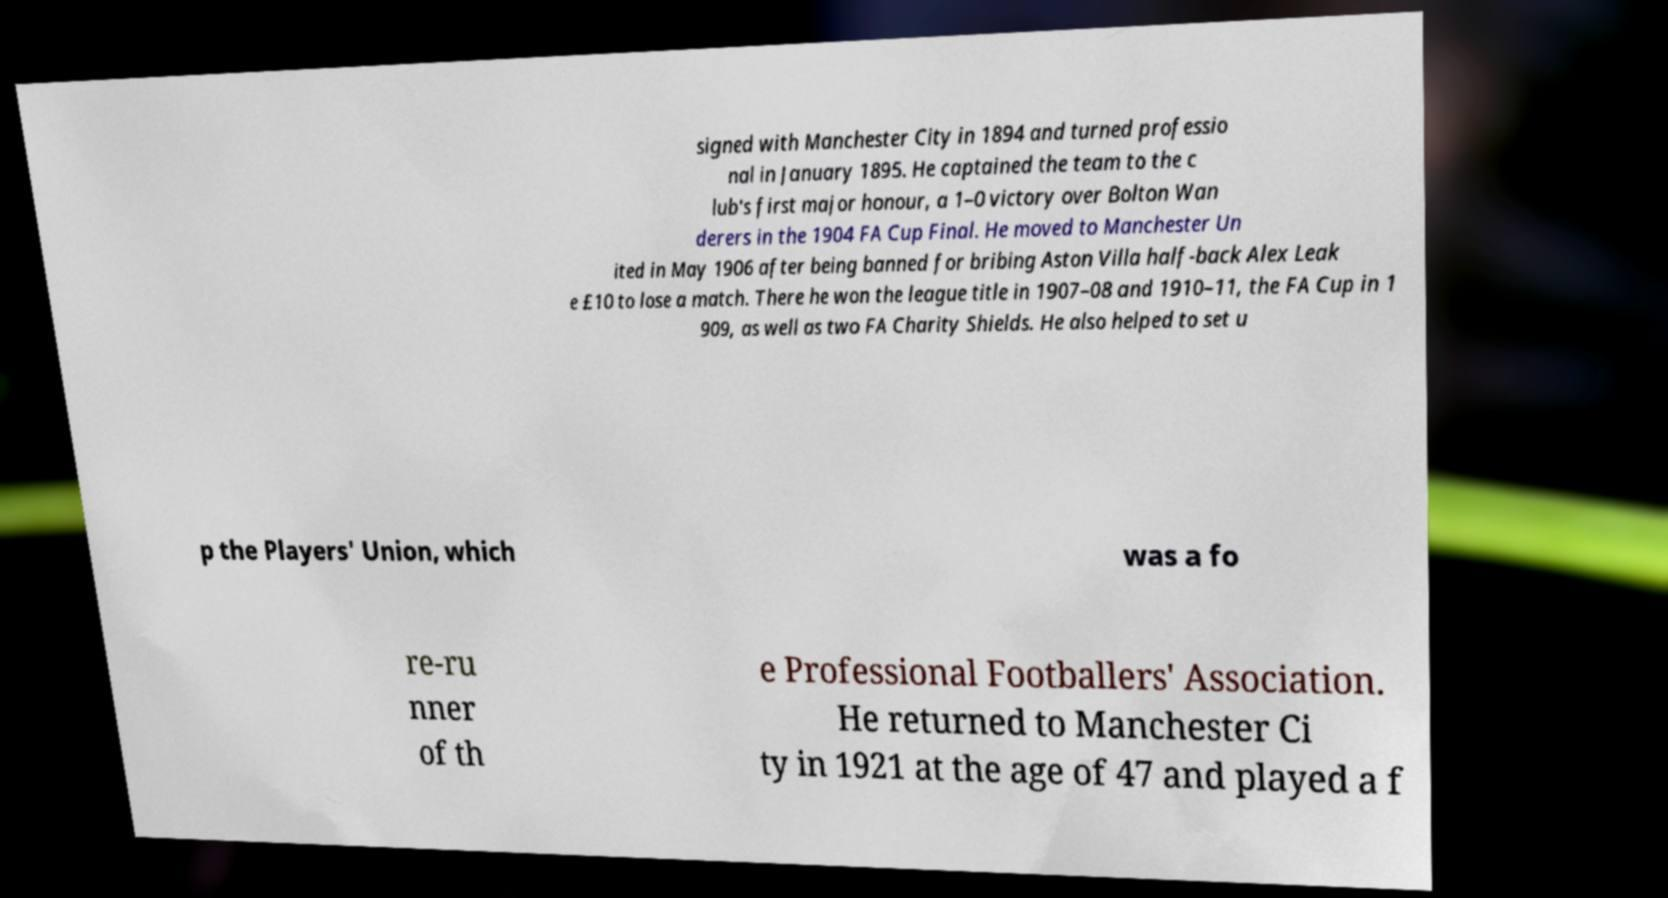I need the written content from this picture converted into text. Can you do that? signed with Manchester City in 1894 and turned professio nal in January 1895. He captained the team to the c lub's first major honour, a 1–0 victory over Bolton Wan derers in the 1904 FA Cup Final. He moved to Manchester Un ited in May 1906 after being banned for bribing Aston Villa half-back Alex Leak e £10 to lose a match. There he won the league title in 1907–08 and 1910–11, the FA Cup in 1 909, as well as two FA Charity Shields. He also helped to set u p the Players' Union, which was a fo re-ru nner of th e Professional Footballers' Association. He returned to Manchester Ci ty in 1921 at the age of 47 and played a f 